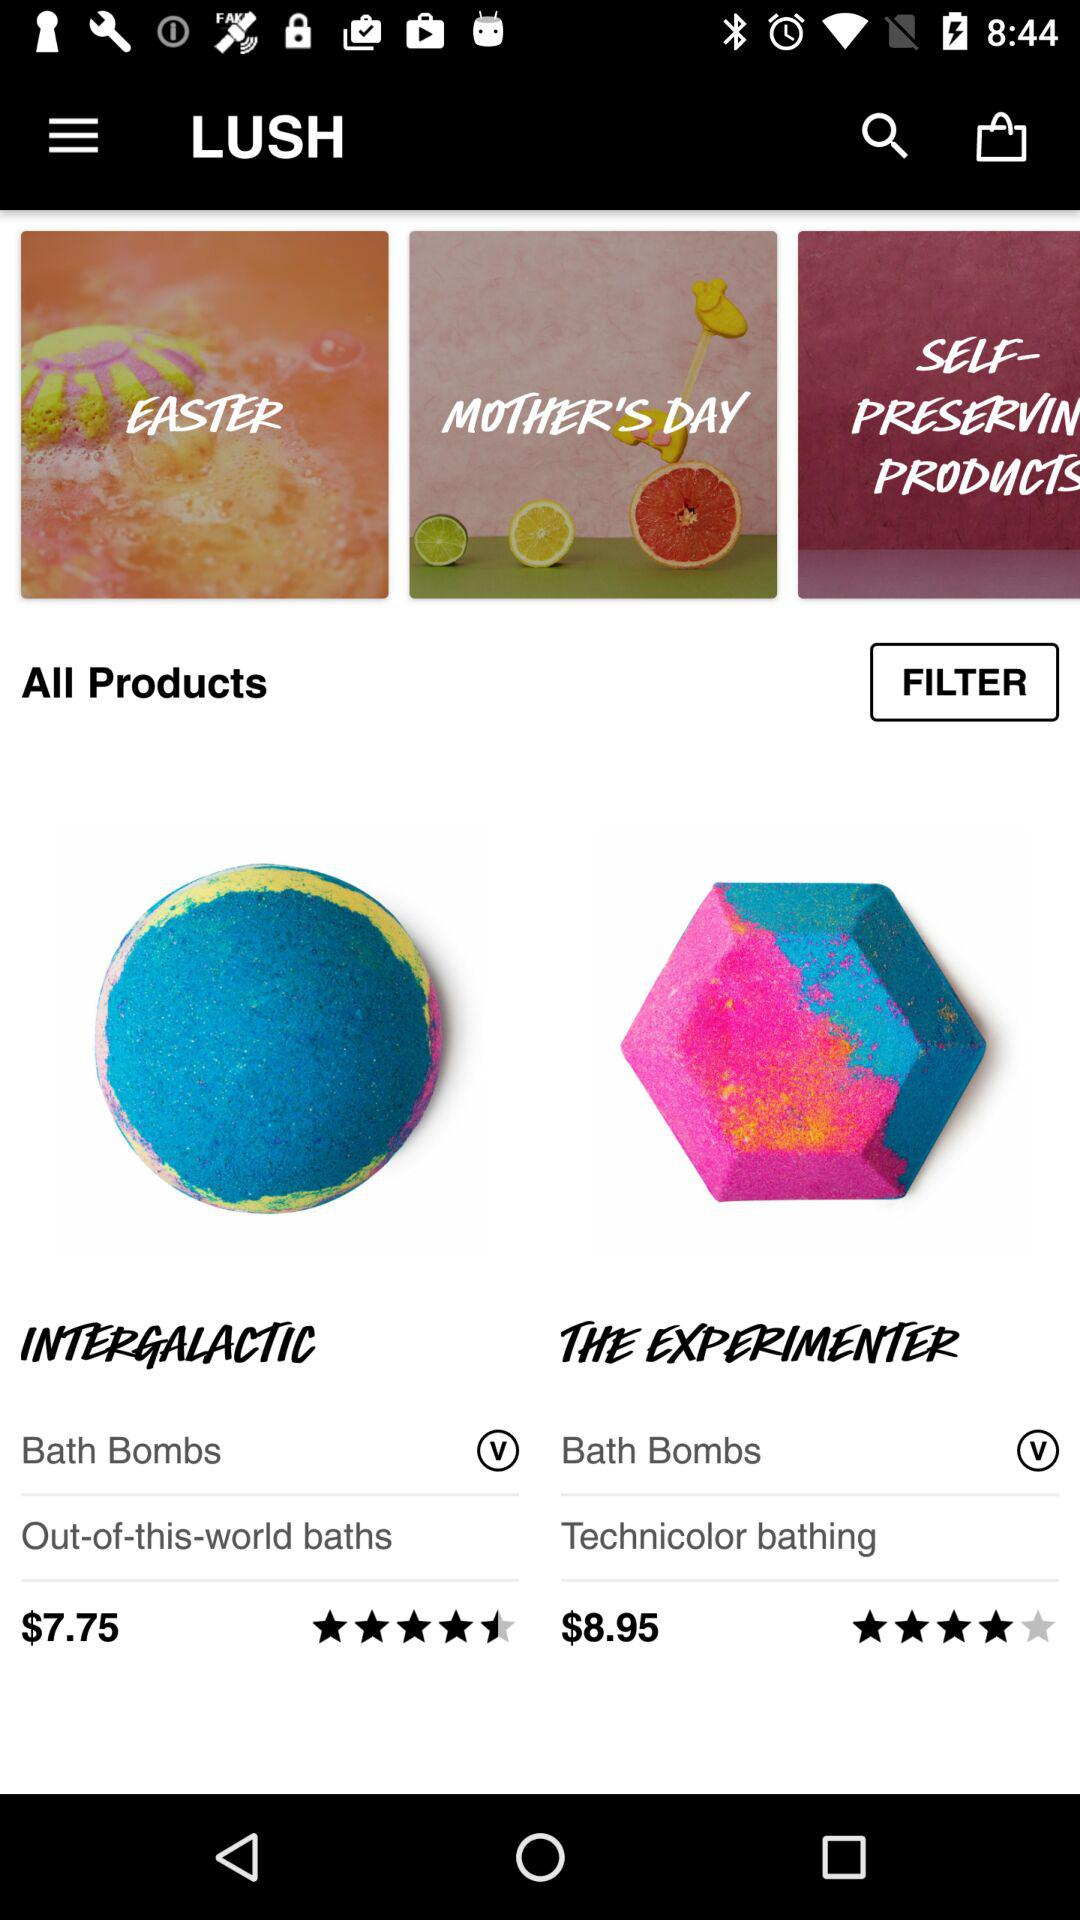What is the rating of "INTERGALACTIC"? The rating is 4.5 stars. 